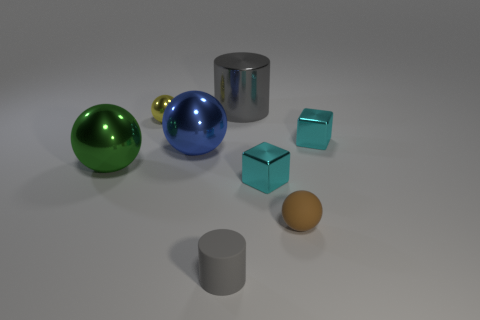Do the blue sphere and the brown sphere have the same size?
Offer a very short reply. No. How many small metal things are both right of the yellow object and behind the large blue object?
Provide a short and direct response. 1. What number of yellow things are either big cylinders or small things?
Ensure brevity in your answer.  1. How many metallic things are big gray cylinders or tiny gray cubes?
Your answer should be very brief. 1. Are there any yellow metal objects?
Your answer should be compact. Yes. Is the shape of the large green object the same as the tiny brown matte thing?
Offer a terse response. Yes. There is a small matte object to the right of the matte object that is to the left of the large gray metal cylinder; how many cyan metallic cubes are in front of it?
Provide a short and direct response. 0. What is the tiny thing that is behind the tiny brown thing and in front of the large green thing made of?
Offer a terse response. Metal. There is a large metal thing that is both on the right side of the small yellow thing and in front of the yellow sphere; what color is it?
Your answer should be very brief. Blue. Is there any other thing that has the same color as the rubber sphere?
Ensure brevity in your answer.  No. 